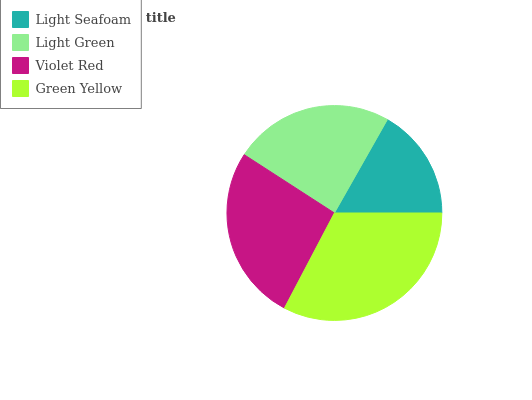Is Light Seafoam the minimum?
Answer yes or no. Yes. Is Green Yellow the maximum?
Answer yes or no. Yes. Is Light Green the minimum?
Answer yes or no. No. Is Light Green the maximum?
Answer yes or no. No. Is Light Green greater than Light Seafoam?
Answer yes or no. Yes. Is Light Seafoam less than Light Green?
Answer yes or no. Yes. Is Light Seafoam greater than Light Green?
Answer yes or no. No. Is Light Green less than Light Seafoam?
Answer yes or no. No. Is Violet Red the high median?
Answer yes or no. Yes. Is Light Green the low median?
Answer yes or no. Yes. Is Light Green the high median?
Answer yes or no. No. Is Violet Red the low median?
Answer yes or no. No. 